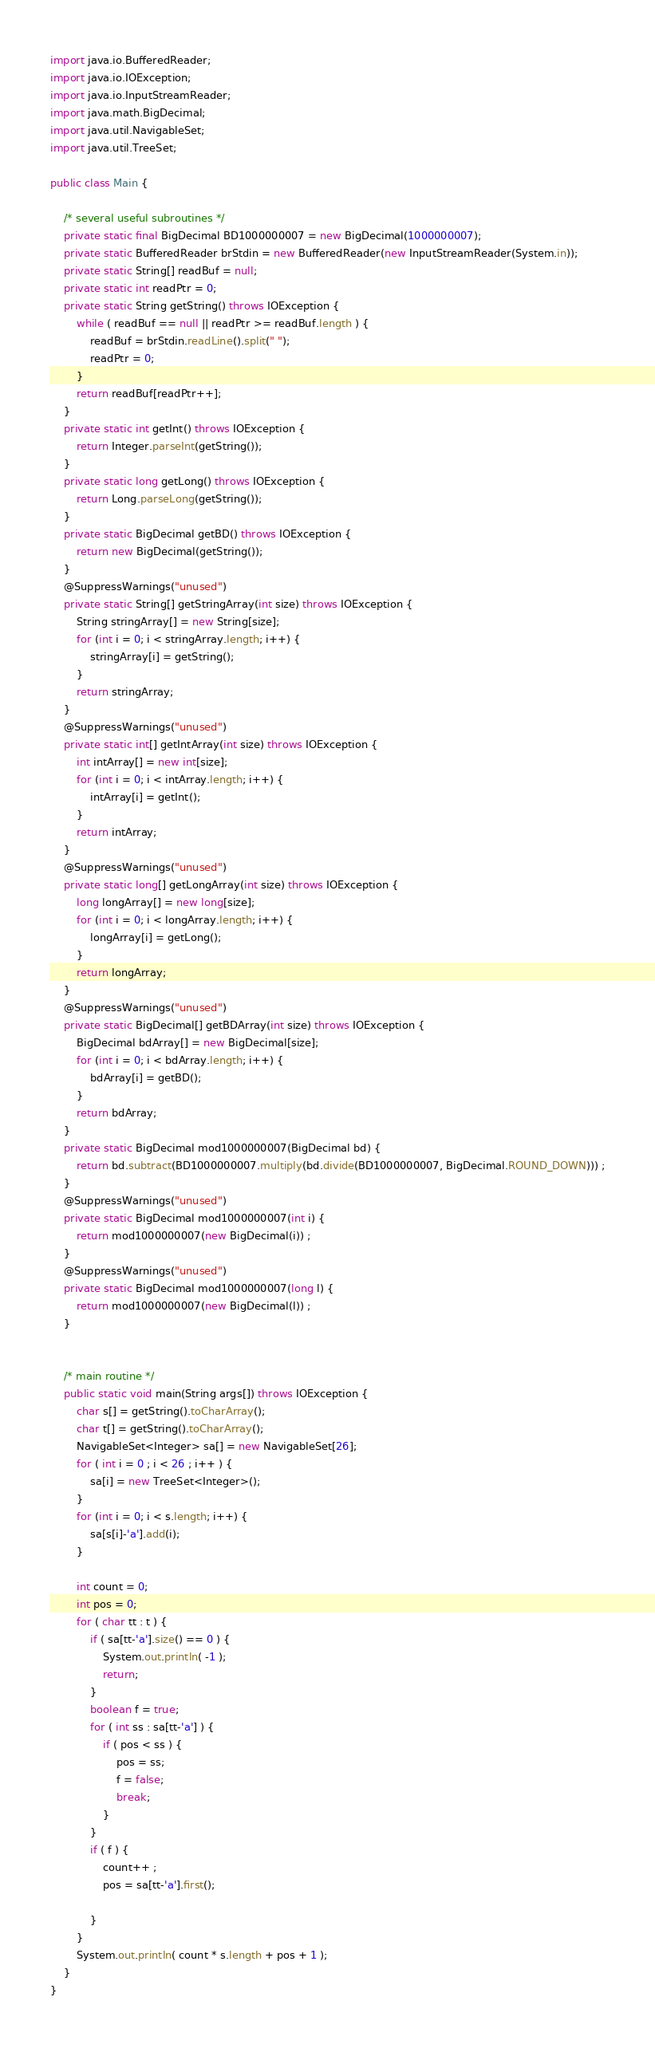<code> <loc_0><loc_0><loc_500><loc_500><_Java_>import java.io.BufferedReader;
import java.io.IOException;
import java.io.InputStreamReader;
import java.math.BigDecimal;
import java.util.NavigableSet;
import java.util.TreeSet;

public class Main {

	/* several useful subroutines */
	private static final BigDecimal BD1000000007 = new BigDecimal(1000000007);
	private static BufferedReader brStdin = new BufferedReader(new InputStreamReader(System.in));
	private static String[] readBuf = null;
	private static int readPtr = 0;
	private static String getString() throws IOException {
		while ( readBuf == null || readPtr >= readBuf.length ) {
			readBuf = brStdin.readLine().split(" ");
			readPtr = 0;
		}
		return readBuf[readPtr++];
	}
	private static int getInt() throws IOException {
		return Integer.parseInt(getString());
	}
	private static long getLong() throws IOException {
		return Long.parseLong(getString());
	}
	private static BigDecimal getBD() throws IOException {
		return new BigDecimal(getString());
	}
	@SuppressWarnings("unused")
	private static String[] getStringArray(int size) throws IOException {
		String stringArray[] = new String[size];
		for (int i = 0; i < stringArray.length; i++) {
			stringArray[i] = getString();
		}
		return stringArray;
	}
	@SuppressWarnings("unused")
	private static int[] getIntArray(int size) throws IOException {
		int intArray[] = new int[size];
		for (int i = 0; i < intArray.length; i++) {
			intArray[i] = getInt();
		}
		return intArray;
	}
	@SuppressWarnings("unused")
	private static long[] getLongArray(int size) throws IOException {
		long longArray[] = new long[size];
		for (int i = 0; i < longArray.length; i++) {
			longArray[i] = getLong();
		}
		return longArray;
	}
	@SuppressWarnings("unused")
	private static BigDecimal[] getBDArray(int size) throws IOException {
		BigDecimal bdArray[] = new BigDecimal[size];
		for (int i = 0; i < bdArray.length; i++) {
			bdArray[i] = getBD();
		}
		return bdArray;
	}
	private static BigDecimal mod1000000007(BigDecimal bd) {
		return bd.subtract(BD1000000007.multiply(bd.divide(BD1000000007, BigDecimal.ROUND_DOWN))) ;
	}
	@SuppressWarnings("unused")
	private static BigDecimal mod1000000007(int i) {
		return mod1000000007(new BigDecimal(i)) ;
	}
	@SuppressWarnings("unused")
	private static BigDecimal mod1000000007(long l) {
		return mod1000000007(new BigDecimal(l)) ;
	}

	
	/* main routine */
	public static void main(String args[]) throws IOException {
		char s[] = getString().toCharArray();
		char t[] = getString().toCharArray();
		NavigableSet<Integer> sa[] = new NavigableSet[26];
		for ( int i = 0 ; i < 26 ; i++ ) {
			sa[i] = new TreeSet<Integer>();
		}
		for (int i = 0; i < s.length; i++) {
			sa[s[i]-'a'].add(i);
		}

		int count = 0;
		int pos = 0;
		for ( char tt : t ) {
			if ( sa[tt-'a'].size() == 0 ) {
				System.out.println( -1 );
				return;
			}
			boolean f = true;
			for ( int ss : sa[tt-'a'] ) {
				if ( pos < ss ) {
					pos = ss;
					f = false;
					break;
				}
			}
			if ( f ) {
				count++ ;
				pos = sa[tt-'a'].first();
				
			}
		}
		System.out.println( count * s.length + pos + 1 );
	}
}
</code> 